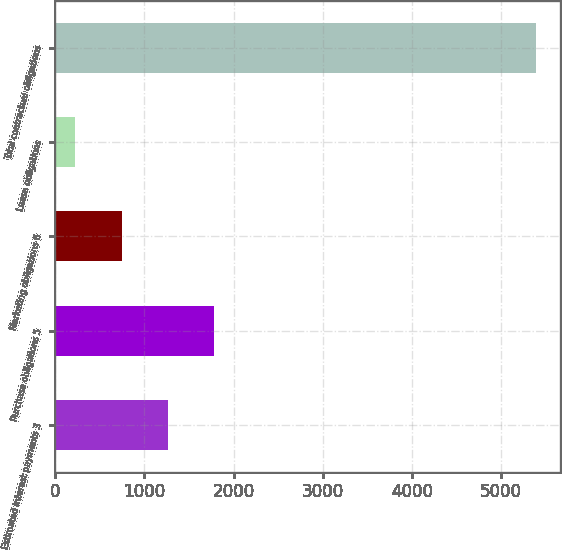Convert chart. <chart><loc_0><loc_0><loc_500><loc_500><bar_chart><fcel>Estimated interest payments 3<fcel>Purchase obligations 5<fcel>Marketing obligations 6<fcel>Lease obligations<fcel>Total contractual obligations<nl><fcel>1259<fcel>1775.5<fcel>742.5<fcel>226<fcel>5391<nl></chart> 